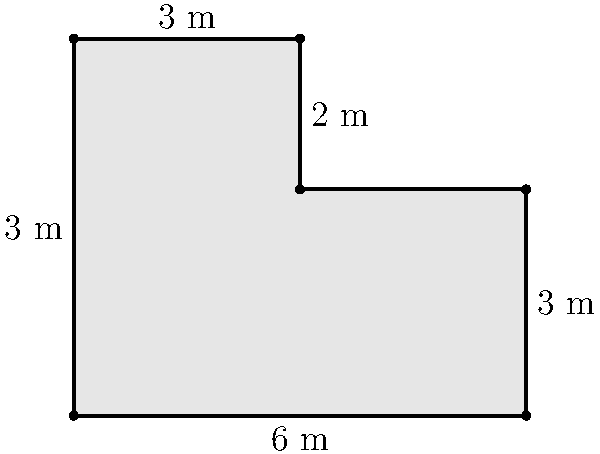An irregularly shaped mosaic floor pattern has been discovered in an excavated Roman villa. The pattern forms a polygon with six sides, as shown in the diagram. Given the measurements provided, what is the perimeter of this mosaic floor pattern in meters? To find the perimeter of the mosaic floor pattern, we need to sum up the lengths of all sides:

1. Bottom side: $6$ m
2. Right side: $3$ m
3. Upper-right side: $3$ m
4. Upper side: $3$ m
5. Left side: $5$ m
6. Lower-left side: $3$ m (this is not explicitly given, but can be deduced from the difference between the total height of 5 m and the upper-right side length of 2 m)

Adding all these lengths:

$$6 + 3 + 3 + 3 + 5 + 3 = 23$$

Therefore, the total perimeter of the mosaic floor pattern is 23 meters.
Answer: 23 m 